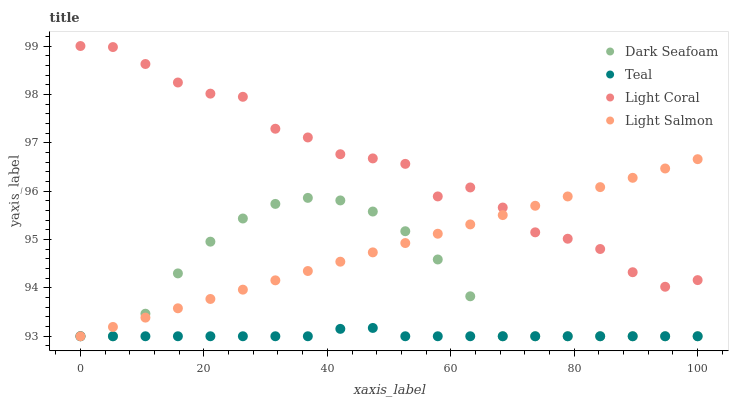Does Teal have the minimum area under the curve?
Answer yes or no. Yes. Does Light Coral have the maximum area under the curve?
Answer yes or no. Yes. Does Dark Seafoam have the minimum area under the curve?
Answer yes or no. No. Does Dark Seafoam have the maximum area under the curve?
Answer yes or no. No. Is Light Salmon the smoothest?
Answer yes or no. Yes. Is Light Coral the roughest?
Answer yes or no. Yes. Is Dark Seafoam the smoothest?
Answer yes or no. No. Is Dark Seafoam the roughest?
Answer yes or no. No. Does Dark Seafoam have the lowest value?
Answer yes or no. Yes. Does Light Coral have the highest value?
Answer yes or no. Yes. Does Dark Seafoam have the highest value?
Answer yes or no. No. Is Teal less than Light Coral?
Answer yes or no. Yes. Is Light Coral greater than Dark Seafoam?
Answer yes or no. Yes. Does Light Salmon intersect Dark Seafoam?
Answer yes or no. Yes. Is Light Salmon less than Dark Seafoam?
Answer yes or no. No. Is Light Salmon greater than Dark Seafoam?
Answer yes or no. No. Does Teal intersect Light Coral?
Answer yes or no. No. 